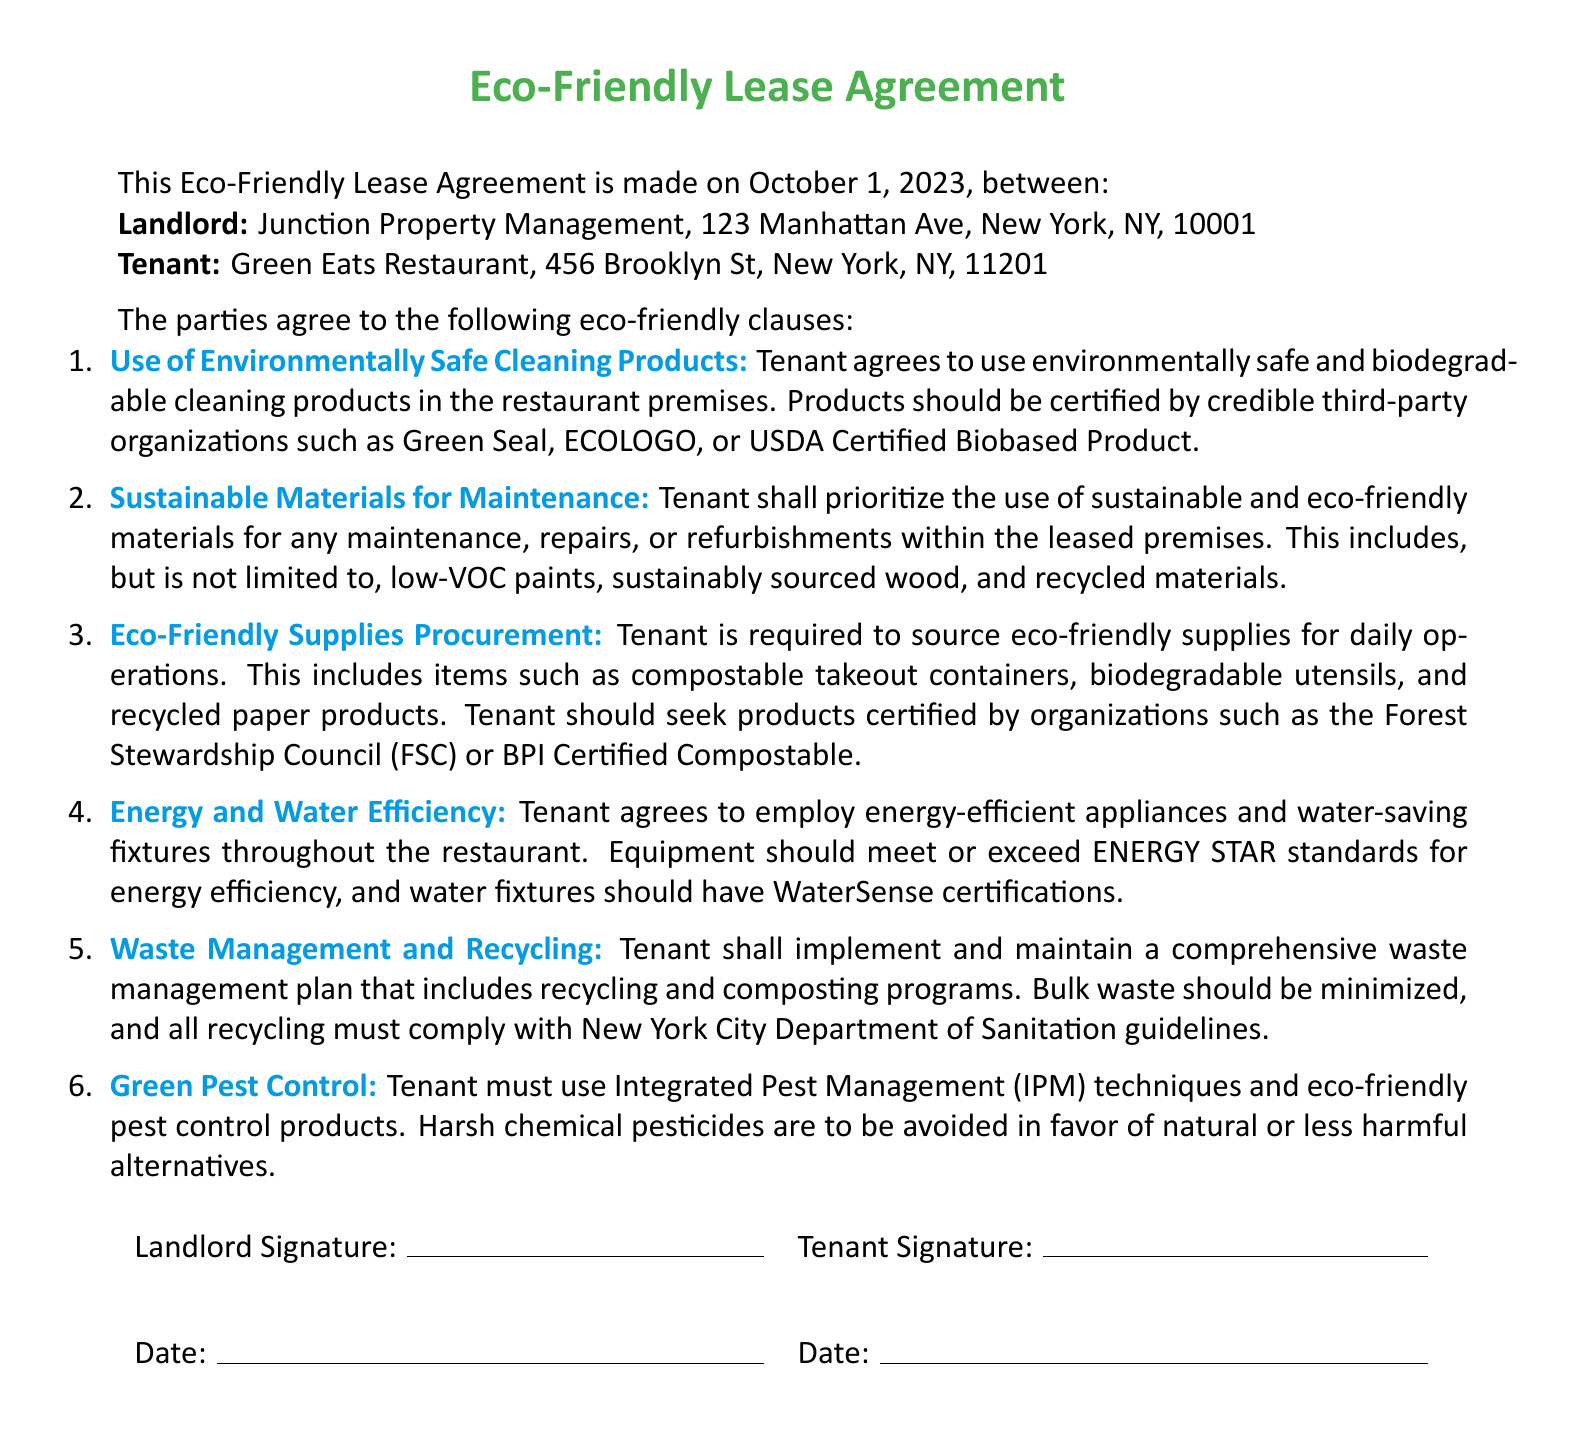what is the name of the landlord? The landlord's name is listed at the beginning of the document as Junction Property Management.
Answer: Junction Property Management what is the rental property address? The rental property address is needed to identify the location of the restaurant. It is 456 Brooklyn St, New York, NY, 11201.
Answer: 456 Brooklyn St, New York, NY, 11201 what is one of the certifications required for cleaning products? Certifications are listed to ensure the use of safe products. One of the required certifications is Green Seal.
Answer: Green Seal what type of maintenance materials should be prioritized? The document specifies that the tenant shall prioritize the use of sustainable and eco-friendly materials for maintenance.
Answer: Sustainable and eco-friendly materials what is one of the waste management requirements? The waste management requirements include implementing a recycling and composting program as part of the tenant’s responsibilities.
Answer: Comprehensive waste management plan how many eco-friendly lease clauses are listed? The document enumerates the clauses which indicates how many are included. There are six eco-friendly lease clauses.
Answer: Six what must the tenant use for pest control? The agreement outlines that the tenant must use Integrated Pest Management (IPM) techniques for pest control.
Answer: Integrated Pest Management (IPM) how does the tenant procure supplies? The document instructs the tenant on sourcing supplies, indicating they should be eco-friendly.
Answer: Eco-friendly supplies when was the eco-friendly lease agreement made? The date of the agreement is mentioned at the top. It was made on October 1, 2023.
Answer: October 1, 2023 